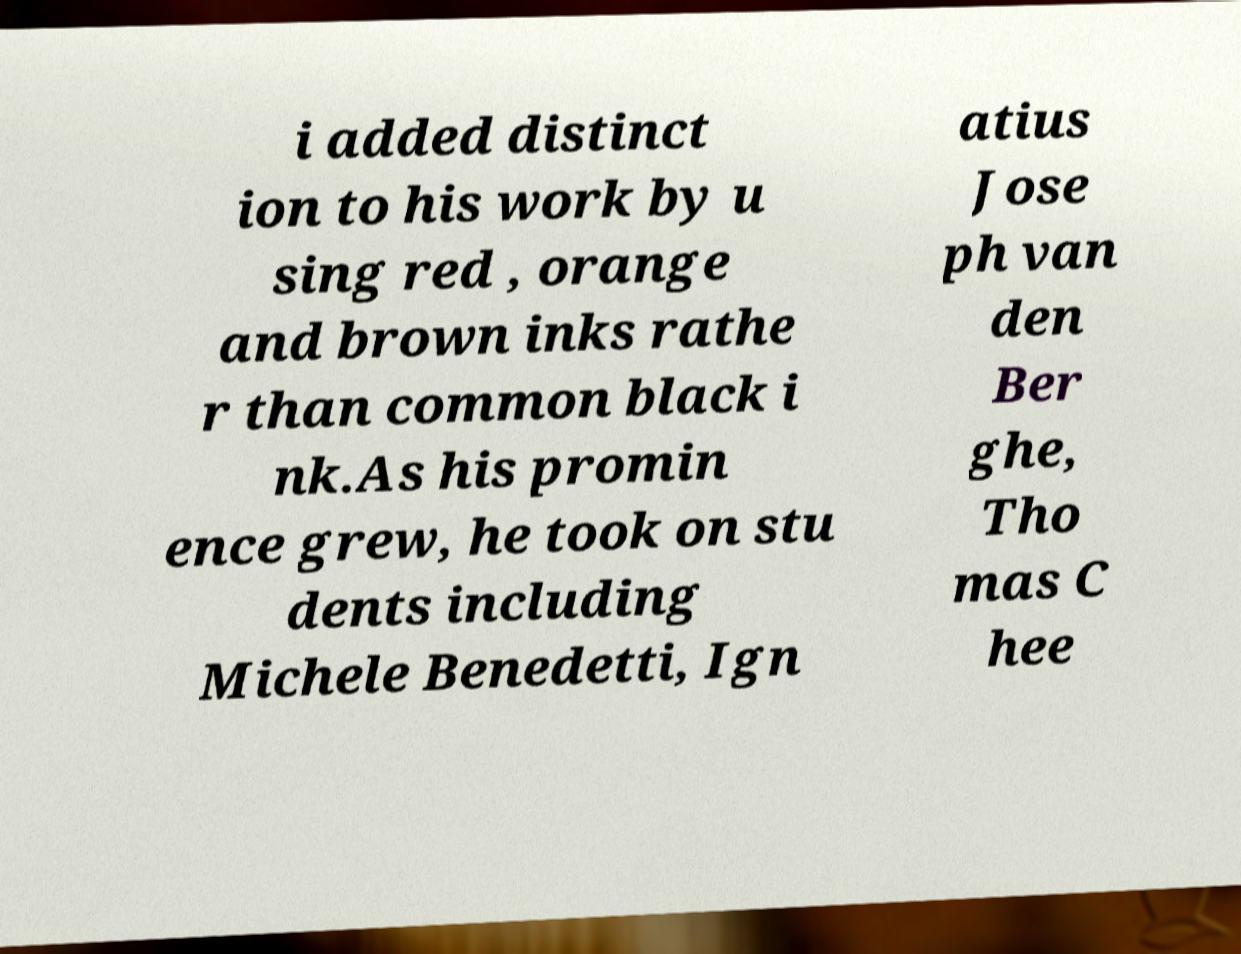Please identify and transcribe the text found in this image. i added distinct ion to his work by u sing red , orange and brown inks rathe r than common black i nk.As his promin ence grew, he took on stu dents including Michele Benedetti, Ign atius Jose ph van den Ber ghe, Tho mas C hee 